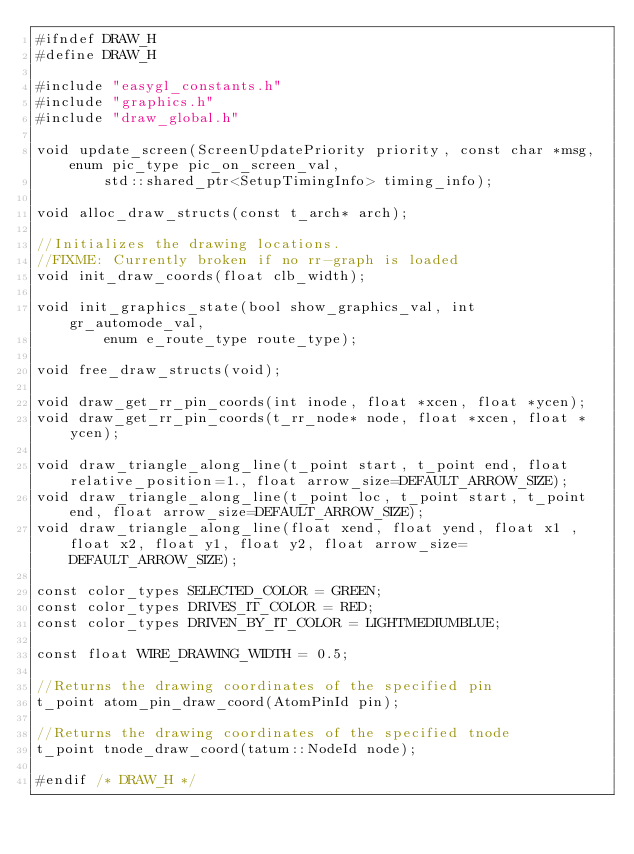<code> <loc_0><loc_0><loc_500><loc_500><_C_>#ifndef DRAW_H
#define DRAW_H

#include "easygl_constants.h"
#include "graphics.h"
#include "draw_global.h"

void update_screen(ScreenUpdatePriority priority, const char *msg, enum pic_type pic_on_screen_val,
		std::shared_ptr<SetupTimingInfo> timing_info);

void alloc_draw_structs(const t_arch* arch);

//Initializes the drawing locations.
//FIXME: Currently broken if no rr-graph is loaded
void init_draw_coords(float clb_width);

void init_graphics_state(bool show_graphics_val, int gr_automode_val,
		enum e_route_type route_type);

void free_draw_structs(void);

void draw_get_rr_pin_coords(int inode, float *xcen, float *ycen);
void draw_get_rr_pin_coords(t_rr_node* node, float *xcen, float *ycen);

void draw_triangle_along_line(t_point start, t_point end, float relative_position=1., float arrow_size=DEFAULT_ARROW_SIZE);
void draw_triangle_along_line(t_point loc, t_point start, t_point end, float arrow_size=DEFAULT_ARROW_SIZE);
void draw_triangle_along_line(float xend, float yend, float x1 ,float x2, float y1, float y2, float arrow_size=DEFAULT_ARROW_SIZE);

const color_types SELECTED_COLOR = GREEN;
const color_types DRIVES_IT_COLOR = RED;
const color_types DRIVEN_BY_IT_COLOR = LIGHTMEDIUMBLUE;

const float WIRE_DRAWING_WIDTH = 0.5;

//Returns the drawing coordinates of the specified pin
t_point atom_pin_draw_coord(AtomPinId pin);

//Returns the drawing coordinates of the specified tnode
t_point tnode_draw_coord(tatum::NodeId node);

#endif /* DRAW_H */
</code> 